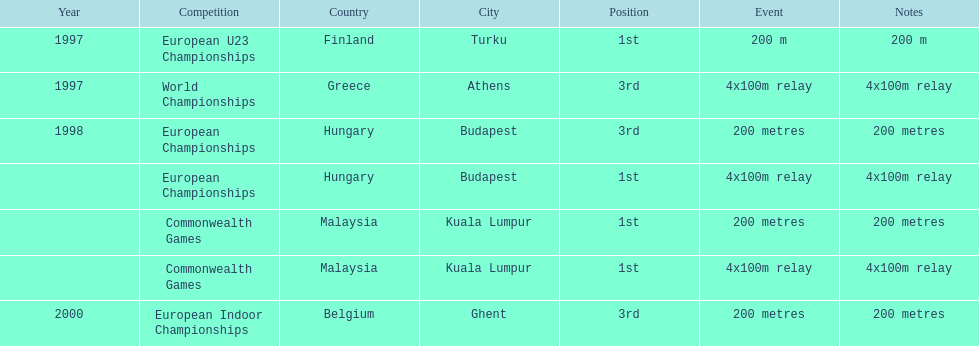What was the only event won in belgium? European Indoor Championships. 